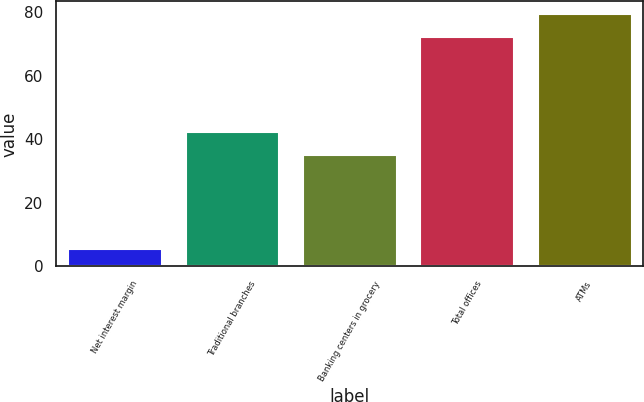<chart> <loc_0><loc_0><loc_500><loc_500><bar_chart><fcel>Net interest margin<fcel>Traditional branches<fcel>Banking centers in grocery<fcel>Total offices<fcel>ATMs<nl><fcel>5.46<fcel>42.35<fcel>35<fcel>72<fcel>79.35<nl></chart> 